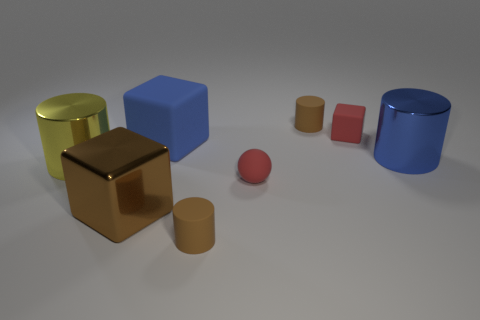Are there any objects that have the same material as the tiny cube? Yes, the material of the tiny cube appears to be a matte finish similar to the small and large cylinders, distinguished from the reflective surfaces of the other objects. 